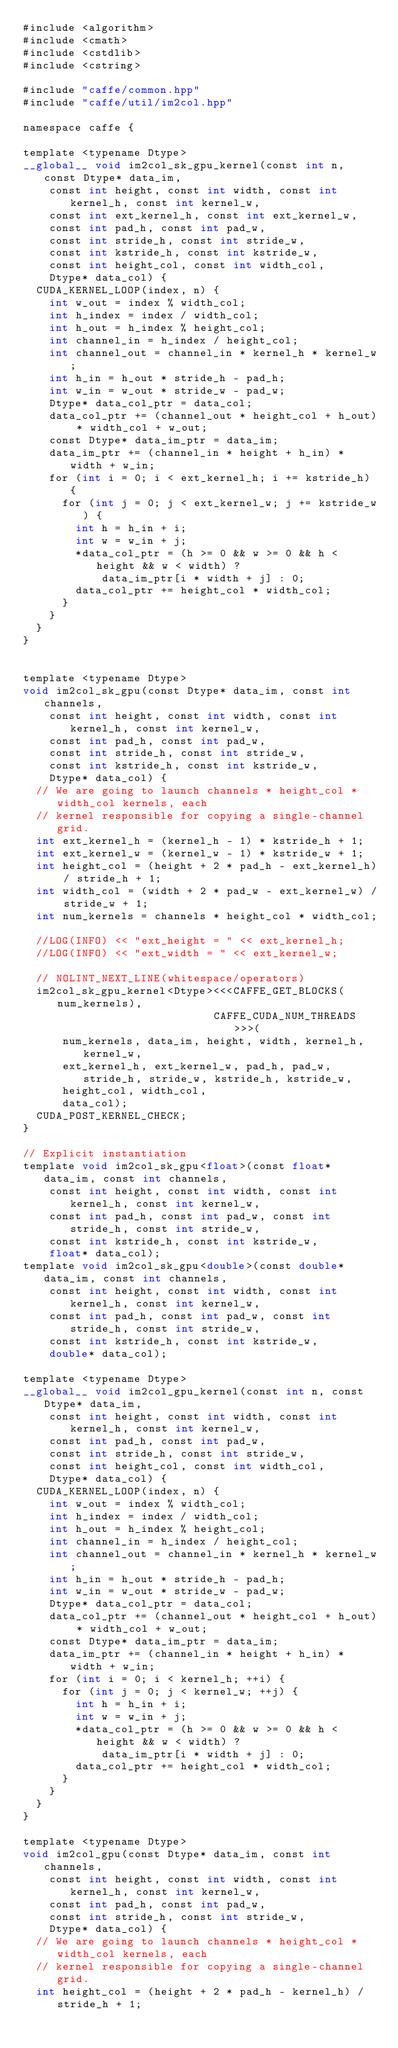Convert code to text. <code><loc_0><loc_0><loc_500><loc_500><_Cuda_>#include <algorithm>
#include <cmath>
#include <cstdlib>
#include <cstring>

#include "caffe/common.hpp"
#include "caffe/util/im2col.hpp"

namespace caffe {

template <typename Dtype>
__global__ void im2col_sk_gpu_kernel(const int n, const Dtype* data_im,
    const int height, const int width, const int kernel_h, const int kernel_w,
    const int ext_kernel_h, const int ext_kernel_w,
    const int pad_h, const int pad_w,
    const int stride_h, const int stride_w,
    const int kstride_h, const int kstride_w,
    const int height_col, const int width_col,
    Dtype* data_col) {
  CUDA_KERNEL_LOOP(index, n) {
    int w_out = index % width_col;
    int h_index = index / width_col;
    int h_out = h_index % height_col;
    int channel_in = h_index / height_col;
    int channel_out = channel_in * kernel_h * kernel_w;
    int h_in = h_out * stride_h - pad_h;
    int w_in = w_out * stride_w - pad_w;
    Dtype* data_col_ptr = data_col;
    data_col_ptr += (channel_out * height_col + h_out) * width_col + w_out;
    const Dtype* data_im_ptr = data_im;
    data_im_ptr += (channel_in * height + h_in) * width + w_in;
    for (int i = 0; i < ext_kernel_h; i += kstride_h) {
      for (int j = 0; j < ext_kernel_w; j += kstride_w) {
        int h = h_in + i;
        int w = w_in + j;
        *data_col_ptr = (h >= 0 && w >= 0 && h < height && w < width) ?
            data_im_ptr[i * width + j] : 0;
        data_col_ptr += height_col * width_col;
      }
    }
  }
}


template <typename Dtype>
void im2col_sk_gpu(const Dtype* data_im, const int channels,
    const int height, const int width, const int kernel_h, const int kernel_w,
    const int pad_h, const int pad_w,
    const int stride_h, const int stride_w,
    const int kstride_h, const int kstride_w,
    Dtype* data_col) {
  // We are going to launch channels * height_col * width_col kernels, each
  // kernel responsible for copying a single-channel grid.
  int ext_kernel_h = (kernel_h - 1) * kstride_h + 1;
  int ext_kernel_w = (kernel_w - 1) * kstride_w + 1;
  int height_col = (height + 2 * pad_h - ext_kernel_h) / stride_h + 1;
  int width_col = (width + 2 * pad_w - ext_kernel_w) / stride_w + 1;
  int num_kernels = channels * height_col * width_col;

  //LOG(INFO) << "ext_height = " << ext_kernel_h;
  //LOG(INFO) << "ext_width = " << ext_kernel_w;

  // NOLINT_NEXT_LINE(whitespace/operators)
  im2col_sk_gpu_kernel<Dtype><<<CAFFE_GET_BLOCKS(num_kernels),
                             CAFFE_CUDA_NUM_THREADS>>>(
      num_kernels, data_im, height, width, kernel_h, kernel_w,
      ext_kernel_h, ext_kernel_w, pad_h, pad_w, stride_h, stride_w, kstride_h, kstride_w,
      height_col, width_col, 
      data_col);
  CUDA_POST_KERNEL_CHECK;
}

// Explicit instantiation
template void im2col_sk_gpu<float>(const float* data_im, const int channels,
    const int height, const int width, const int kernel_h, const int kernel_w,
    const int pad_h, const int pad_w, const int stride_h, const int stride_w,
    const int kstride_h, const int kstride_w,
    float* data_col);
template void im2col_sk_gpu<double>(const double* data_im, const int channels,
    const int height, const int width, const int kernel_h, const int kernel_w,
    const int pad_h, const int pad_w, const int stride_h, const int stride_w,
    const int kstride_h, const int kstride_w,
    double* data_col);

template <typename Dtype>
__global__ void im2col_gpu_kernel(const int n, const Dtype* data_im,
    const int height, const int width, const int kernel_h, const int kernel_w,
    const int pad_h, const int pad_w,
    const int stride_h, const int stride_w,
    const int height_col, const int width_col,
    Dtype* data_col) {
  CUDA_KERNEL_LOOP(index, n) {
    int w_out = index % width_col;
    int h_index = index / width_col;
    int h_out = h_index % height_col;
    int channel_in = h_index / height_col;
    int channel_out = channel_in * kernel_h * kernel_w;
    int h_in = h_out * stride_h - pad_h;
    int w_in = w_out * stride_w - pad_w;
    Dtype* data_col_ptr = data_col;
    data_col_ptr += (channel_out * height_col + h_out) * width_col + w_out;
    const Dtype* data_im_ptr = data_im;
    data_im_ptr += (channel_in * height + h_in) * width + w_in;
    for (int i = 0; i < kernel_h; ++i) {
      for (int j = 0; j < kernel_w; ++j) {
        int h = h_in + i;
        int w = w_in + j;
        *data_col_ptr = (h >= 0 && w >= 0 && h < height && w < width) ?
            data_im_ptr[i * width + j] : 0;
        data_col_ptr += height_col * width_col;
      }
    }
  }
}

template <typename Dtype>
void im2col_gpu(const Dtype* data_im, const int channels,
    const int height, const int width, const int kernel_h, const int kernel_w,
    const int pad_h, const int pad_w,
    const int stride_h, const int stride_w,
    Dtype* data_col) {
  // We are going to launch channels * height_col * width_col kernels, each
  // kernel responsible for copying a single-channel grid.
  int height_col = (height + 2 * pad_h - kernel_h) / stride_h + 1;</code> 